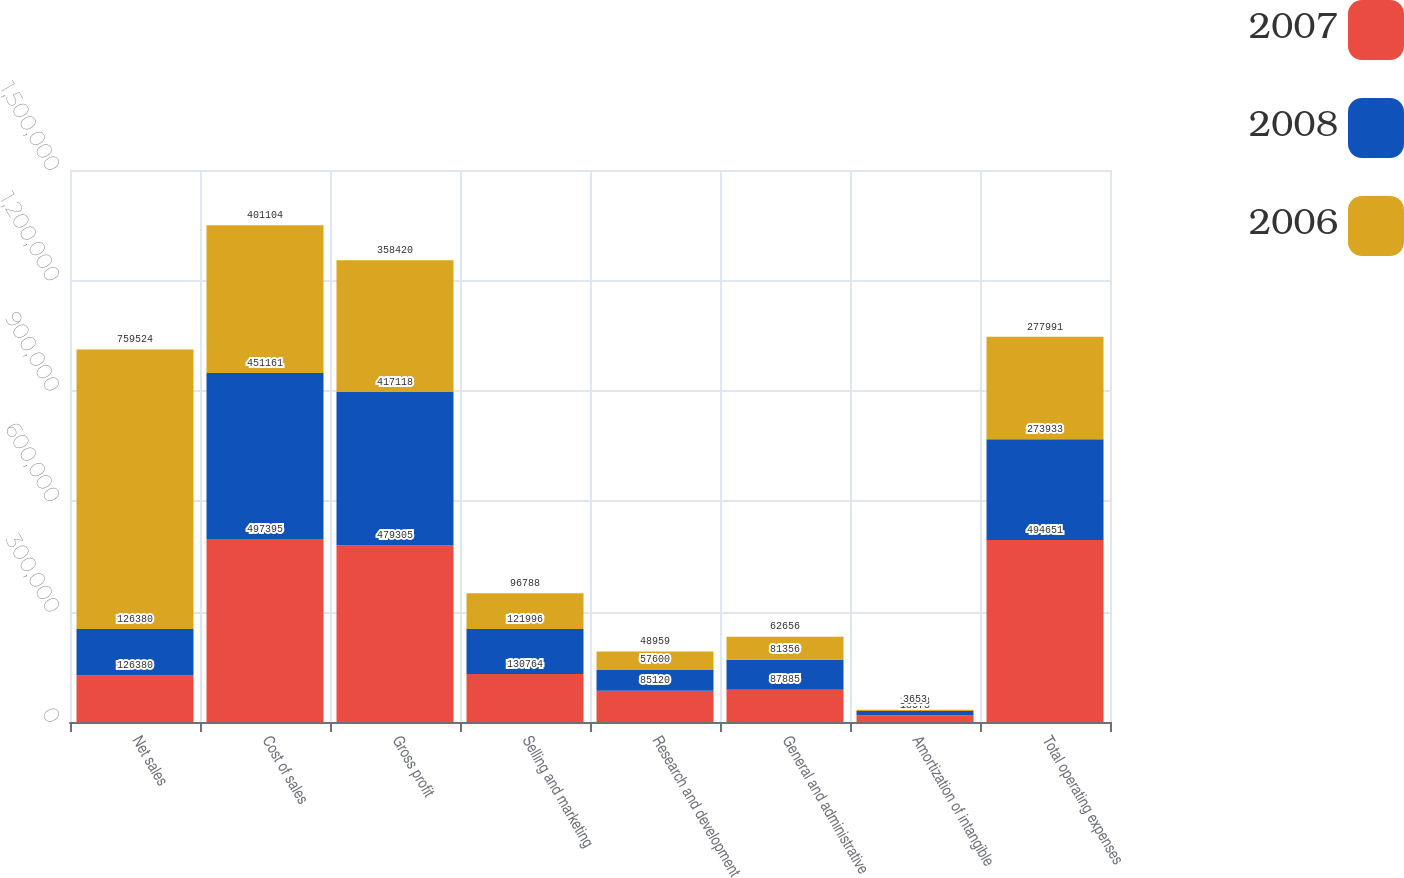Convert chart. <chart><loc_0><loc_0><loc_500><loc_500><stacked_bar_chart><ecel><fcel>Net sales<fcel>Cost of sales<fcel>Gross profit<fcel>Selling and marketing<fcel>Research and development<fcel>General and administrative<fcel>Amortization of intangible<fcel>Total operating expenses<nl><fcel>2007<fcel>126380<fcel>497395<fcel>479305<fcel>130764<fcel>85120<fcel>87885<fcel>18575<fcel>494651<nl><fcel>2008<fcel>126380<fcel>451161<fcel>417118<fcel>121996<fcel>57600<fcel>81356<fcel>11128<fcel>273933<nl><fcel>2006<fcel>759524<fcel>401104<fcel>358420<fcel>96788<fcel>48959<fcel>62656<fcel>3653<fcel>277991<nl></chart> 